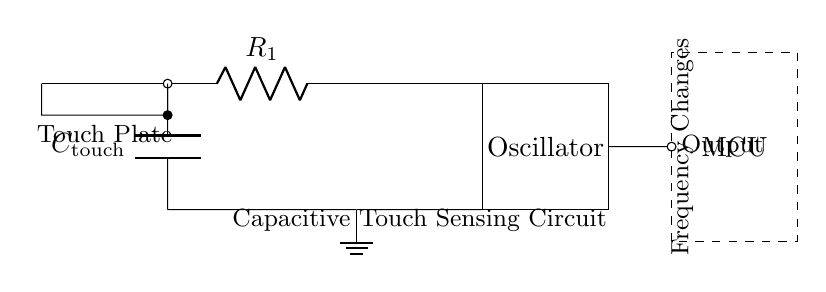What component is labeled R1? R1 is a resistor, as indicated in the circuit diagram with the notation R. Resistors are identified by the letter "R" followed by a number in circuit diagrams.
Answer: Resistor What is the function of the capacitor in this circuit? The capacitor, labeled C touch, serves to store charge and is crucial for the capacitive touch sensing function. It helps detect changes in capacitance when the touch plate is activated.
Answer: Store charge How many connections does the touch plate have? The touch plate has two connections, one leading to the resistor and the other leading to the capacitor. This allows it to interface with both components.
Answer: Two What does the output of this circuit connect to? The output connects to the microcontroller (MCU). This indicates that the processed signal will be sent to the microcontroller for further processing and response.
Answer: Microcontroller What type of circuit is depicted here? This is a capacitive touch sensing circuit, characterized by a combination of resistive and capacitive elements designed to detect touch through the change in capacitance.
Answer: Capacitive touch sensing circuit What does the label "Frequency Changes" indicate? The label "Frequency Changes" indicates that the output signal's frequency varies based on the touch detected at the touch plate. This is a crucial aspect of how the circuit functions in response to user interaction.
Answer: Output frequency changes What component is to the left of the oscillator? The resistor R1 is to the left of the oscillator. Its placement shows the flow of the circuit from the touch plate to the resistor and subsequently to the oscillator.
Answer: Resistor 